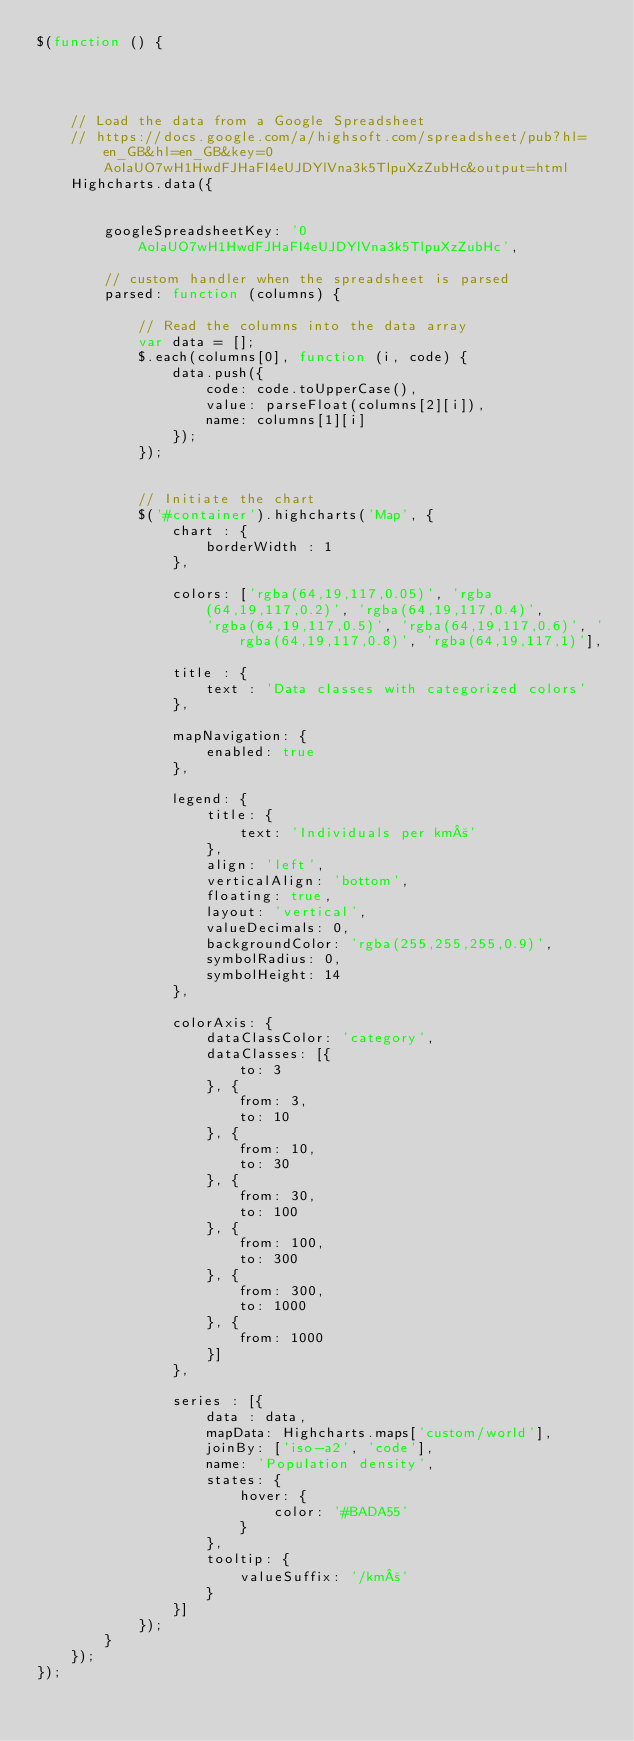<code> <loc_0><loc_0><loc_500><loc_500><_JavaScript_>$(function () {




    // Load the data from a Google Spreadsheet
    // https://docs.google.com/a/highsoft.com/spreadsheet/pub?hl=en_GB&hl=en_GB&key=0AoIaUO7wH1HwdFJHaFI4eUJDYlVna3k5TlpuXzZubHc&output=html
    Highcharts.data({


        googleSpreadsheetKey: '0AoIaUO7wH1HwdFJHaFI4eUJDYlVna3k5TlpuXzZubHc',

        // custom handler when the spreadsheet is parsed
        parsed: function (columns) {

            // Read the columns into the data array
            var data = [];
            $.each(columns[0], function (i, code) {
                data.push({
                    code: code.toUpperCase(),
                    value: parseFloat(columns[2][i]),
                    name: columns[1][i]
                });
            });


            // Initiate the chart
            $('#container').highcharts('Map', {
                chart : {
                    borderWidth : 1
                },

                colors: ['rgba(64,19,117,0.05)', 'rgba(64,19,117,0.2)', 'rgba(64,19,117,0.4)',
                    'rgba(64,19,117,0.5)', 'rgba(64,19,117,0.6)', 'rgba(64,19,117,0.8)', 'rgba(64,19,117,1)'],

                title : {
                    text : 'Data classes with categorized colors'
                },

                mapNavigation: {
                    enabled: true
                },

                legend: {
                    title: {
                        text: 'Individuals per km²'
                    },
                    align: 'left',
                    verticalAlign: 'bottom',
                    floating: true,
                    layout: 'vertical',
                    valueDecimals: 0,
                    backgroundColor: 'rgba(255,255,255,0.9)',
                    symbolRadius: 0,
                    symbolHeight: 14
                },

                colorAxis: {
                    dataClassColor: 'category',
                    dataClasses: [{
                        to: 3
                    }, {
                        from: 3,
                        to: 10
                    }, {
                        from: 10,
                        to: 30
                    }, {
                        from: 30,
                        to: 100
                    }, {
                        from: 100,
                        to: 300
                    }, {
                        from: 300,
                        to: 1000
                    }, {
                        from: 1000
                    }]
                },

                series : [{
                    data : data,
                    mapData: Highcharts.maps['custom/world'],
                    joinBy: ['iso-a2', 'code'],
                    name: 'Population density',
                    states: {
                        hover: {
                            color: '#BADA55'
                        }
                    },
                    tooltip: {
                        valueSuffix: '/km²'
                    }
                }]
            });
        }
    });
});</code> 